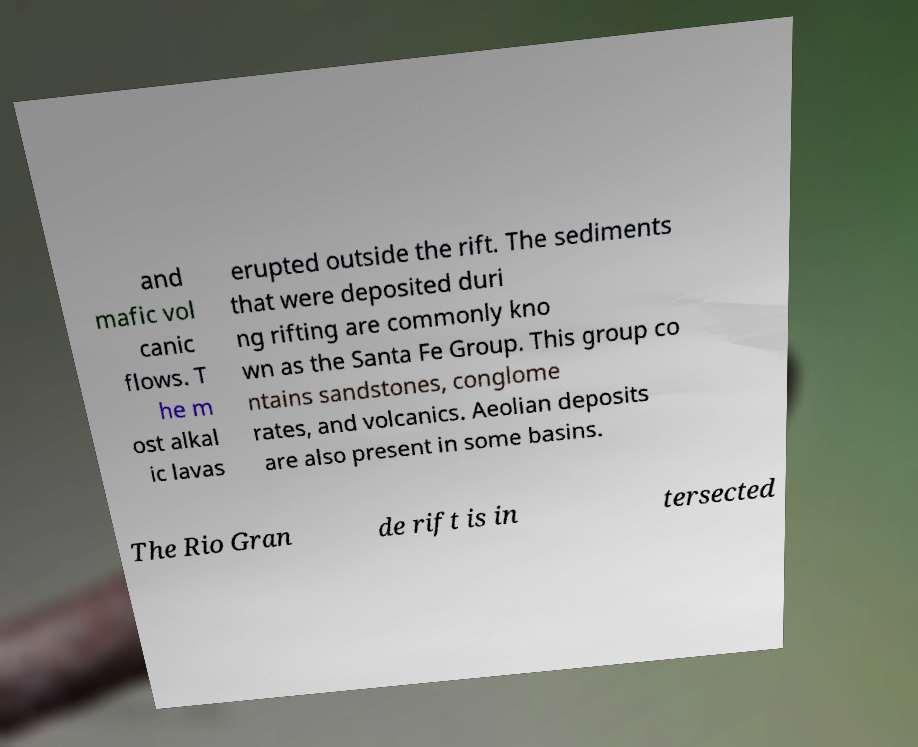There's text embedded in this image that I need extracted. Can you transcribe it verbatim? and mafic vol canic flows. T he m ost alkal ic lavas erupted outside the rift. The sediments that were deposited duri ng rifting are commonly kno wn as the Santa Fe Group. This group co ntains sandstones, conglome rates, and volcanics. Aeolian deposits are also present in some basins. The Rio Gran de rift is in tersected 